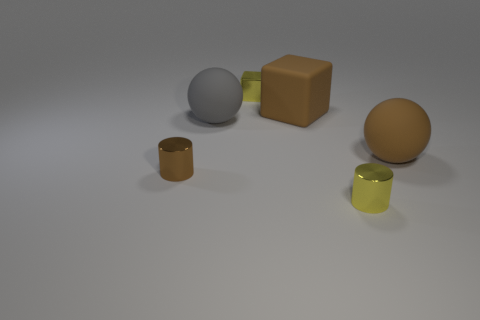Are the objects arranged in any particular pattern? There does not seem to be a specific pattern to the arrangement of the objects. They are placed seemingly at random on a flat surface with ample space around each item, allowing each one to be seen clearly without overlapping. 